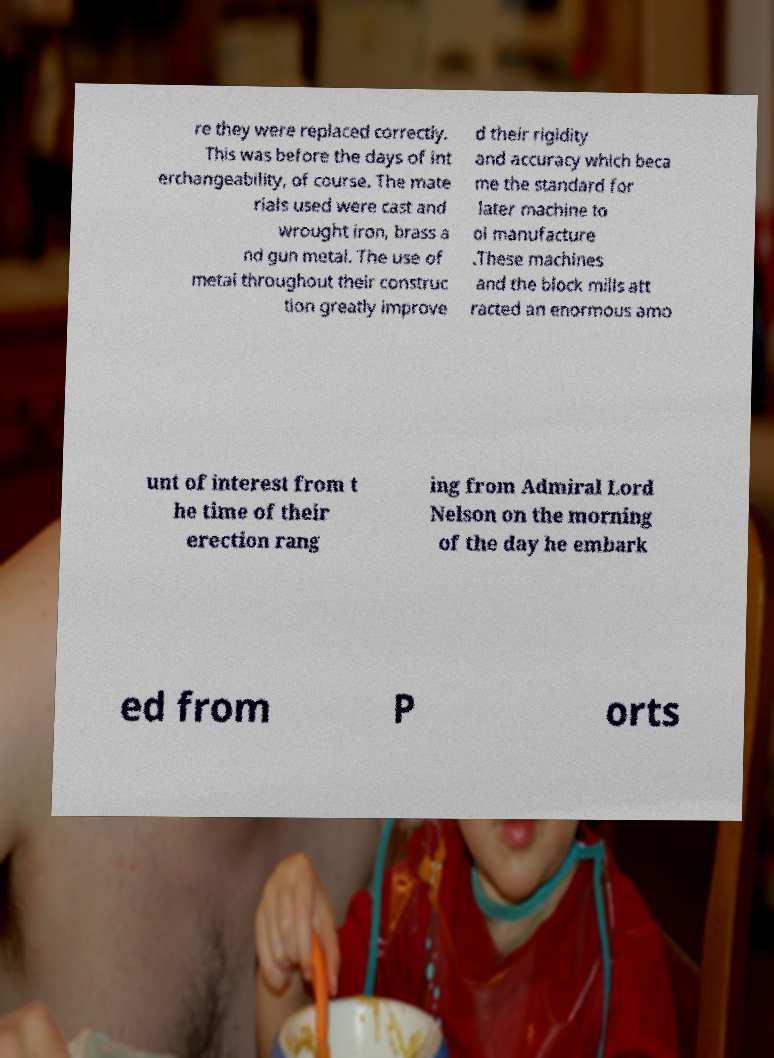Could you extract and type out the text from this image? re they were replaced correctly. This was before the days of int erchangeability, of course. The mate rials used were cast and wrought iron, brass a nd gun metal. The use of metal throughout their construc tion greatly improve d their rigidity and accuracy which beca me the standard for later machine to ol manufacture .These machines and the block mills att racted an enormous amo unt of interest from t he time of their erection rang ing from Admiral Lord Nelson on the morning of the day he embark ed from P orts 